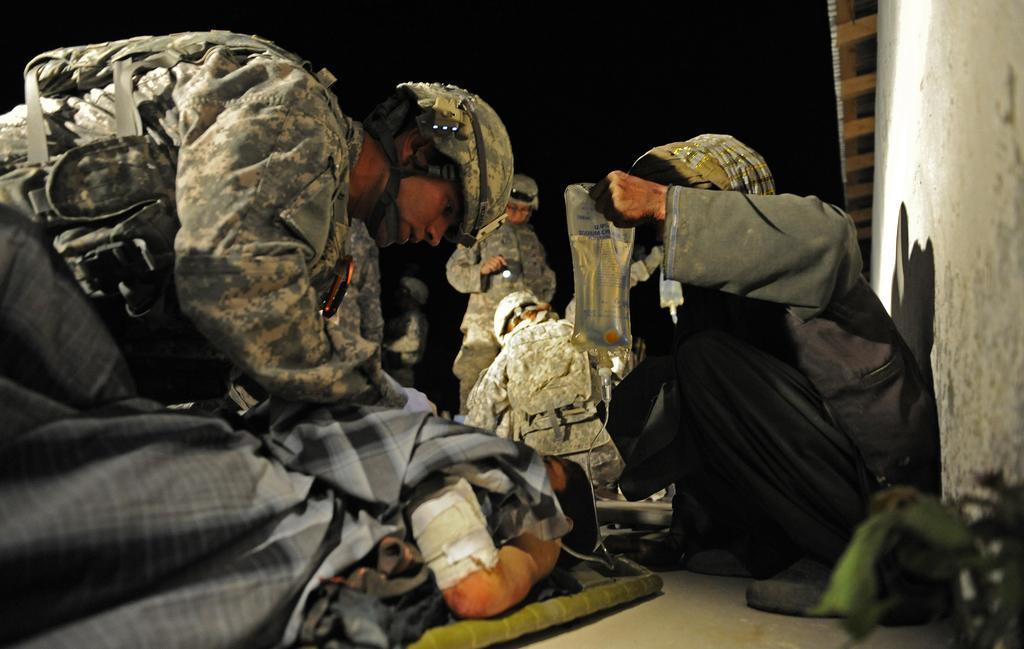In one or two sentences, can you explain what this image depicts? In this picture I can see some army people holding some objects, side I can see the wall with roof. 